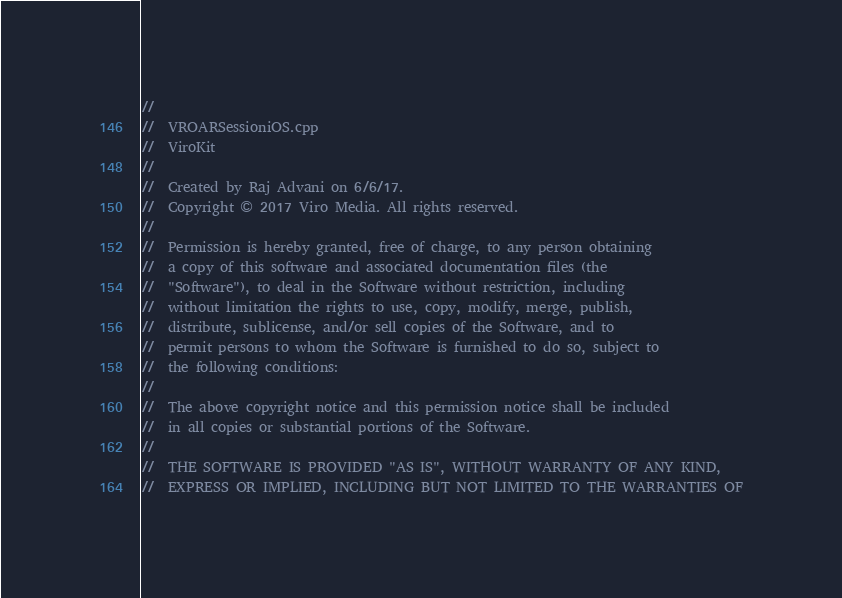<code> <loc_0><loc_0><loc_500><loc_500><_C++_>//
//  VROARSessioniOS.cpp
//  ViroKit
//
//  Created by Raj Advani on 6/6/17.
//  Copyright © 2017 Viro Media. All rights reserved.
//
//  Permission is hereby granted, free of charge, to any person obtaining
//  a copy of this software and associated documentation files (the
//  "Software"), to deal in the Software without restriction, including
//  without limitation the rights to use, copy, modify, merge, publish,
//  distribute, sublicense, and/or sell copies of the Software, and to
//  permit persons to whom the Software is furnished to do so, subject to
//  the following conditions:
//
//  The above copyright notice and this permission notice shall be included
//  in all copies or substantial portions of the Software.
//
//  THE SOFTWARE IS PROVIDED "AS IS", WITHOUT WARRANTY OF ANY KIND,
//  EXPRESS OR IMPLIED, INCLUDING BUT NOT LIMITED TO THE WARRANTIES OF</code> 